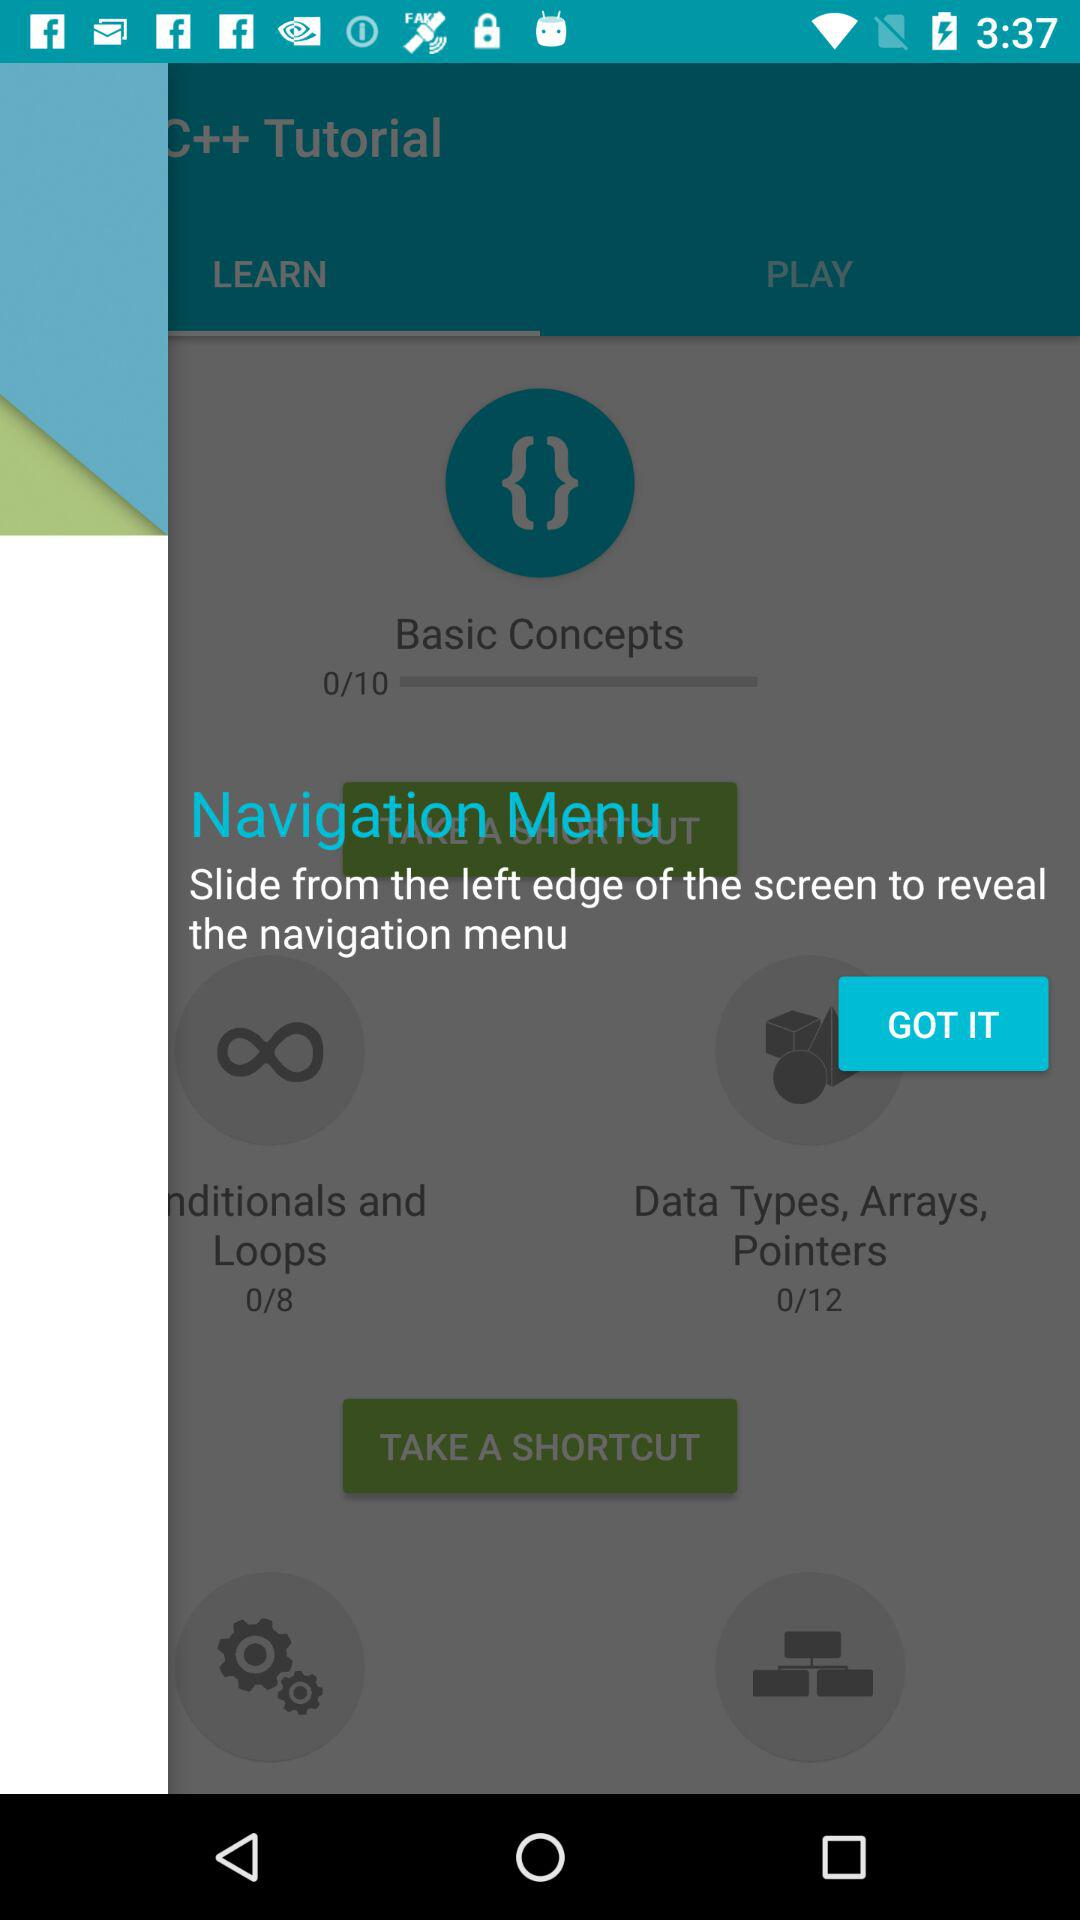What is the total number of modules in "Basic Concepts"? The total number of modules in "Basic Concepts" is 10. 